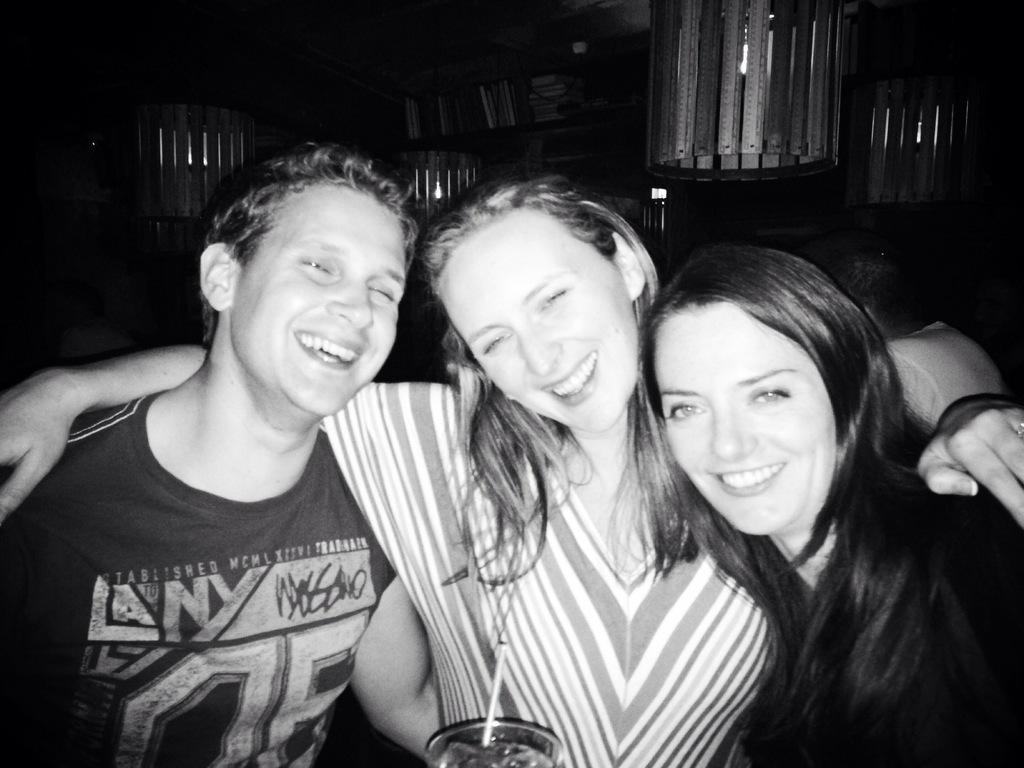Please provide a concise description of this image. In the center of the image we can see three people smiling. In the background there is a shelf. At the top there are lights. 